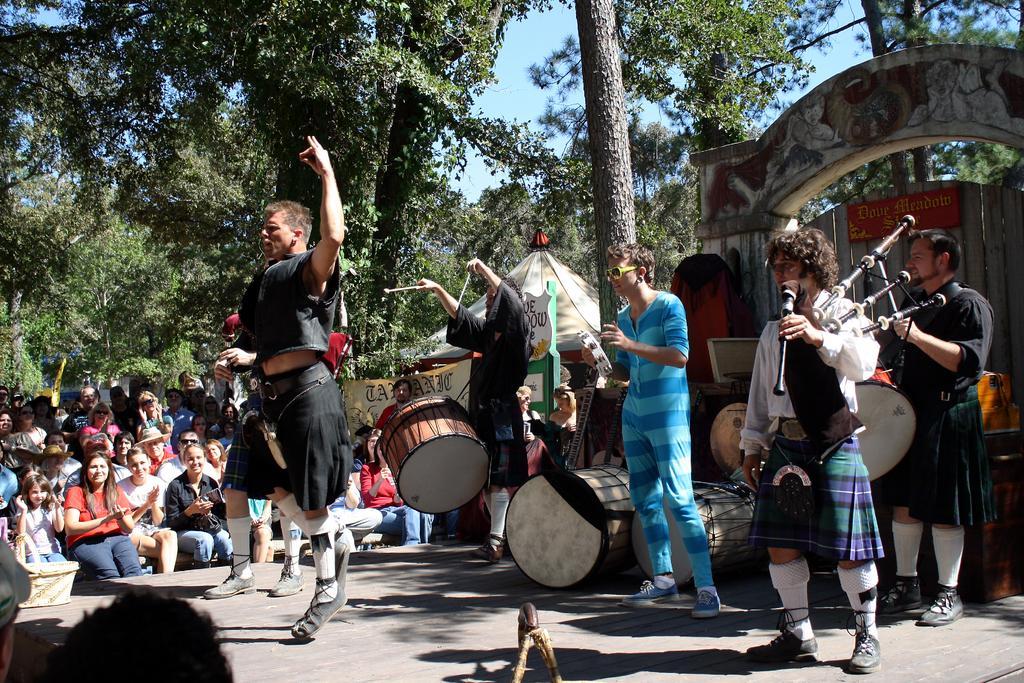Describe this image in one or two sentences. There is there is a group of people watching performance of the actors. And there is a man who wearing black colour shirt he is dancing on the floor. There is a man who is wearing black colour jacket playing drum. And there is man who is wearing blue colour shirt and wearing spectacles standing on the floor. And there is a man holding a micro phone wearing a white colour shirt and white colour shirt and beside the man black colour jacket person playing a musical instrument and beside that man there is a arch and there is a entrance gate and there is a there are some trees on the background and on the background sky is visible and there is a tent on the background. 